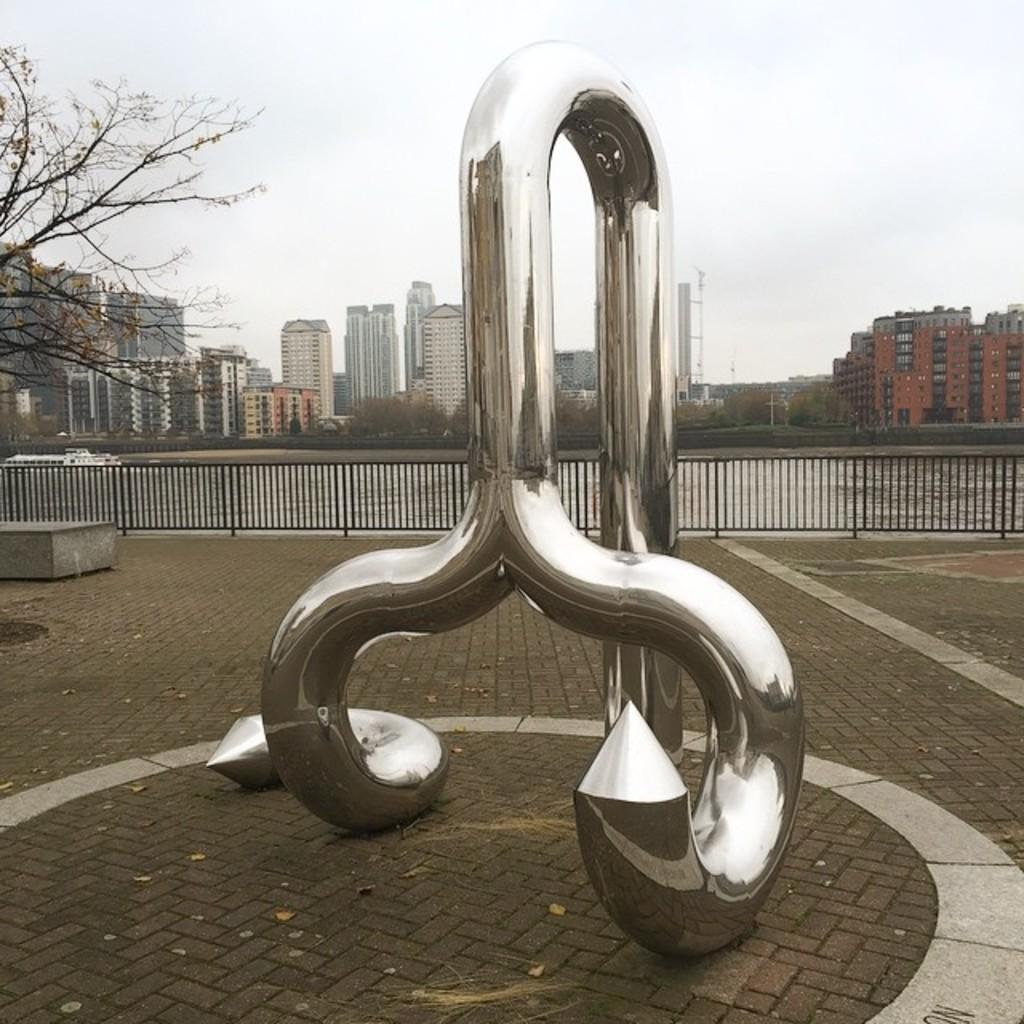What is located on the ground in the image? There is a sculpture on the ground in the image. What type of barrier can be seen in the image? There is a fence in the image. What type of structures are visible in the image? There are buildings with windows in the image. What type of vegetation is present in the image? There are trees in the image. What body of water is visible in the image? There is water visible in the image. What type of vehicle is present in the image? There is a boat in the image. What can be seen in the background of the image? The sky is visible in the background of the image. How many rings are visible on the sculpture in the image? There are no rings present on the sculpture in the image. What type of utensil is being used to stir the water in the image? There is no spoon or stirring activity present in the image. 